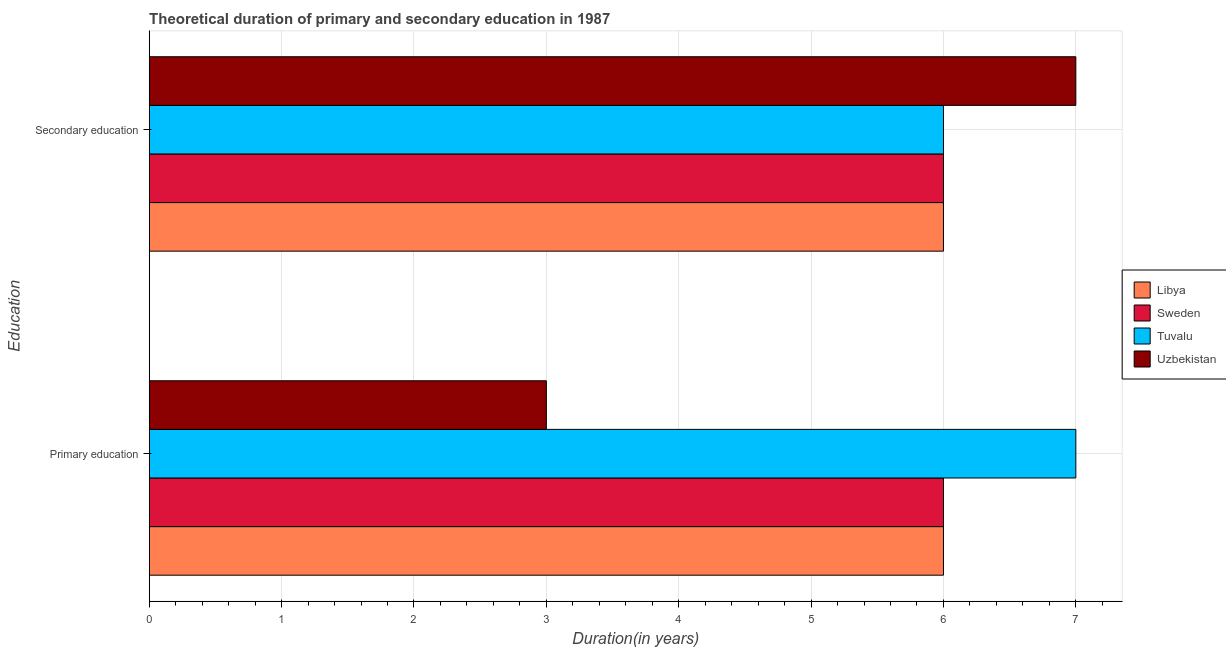Are the number of bars on each tick of the Y-axis equal?
Provide a short and direct response. Yes. What is the label of the 1st group of bars from the top?
Make the answer very short. Secondary education. Across all countries, what is the maximum duration of primary education?
Keep it short and to the point. 7. Across all countries, what is the minimum duration of primary education?
Your answer should be very brief. 3. In which country was the duration of primary education maximum?
Ensure brevity in your answer.  Tuvalu. In which country was the duration of primary education minimum?
Offer a terse response. Uzbekistan. What is the total duration of secondary education in the graph?
Your answer should be compact. 25. What is the difference between the duration of primary education in Uzbekistan and that in Tuvalu?
Ensure brevity in your answer.  -4. What is the difference between the duration of secondary education in Sweden and the duration of primary education in Uzbekistan?
Ensure brevity in your answer.  3. What is the average duration of primary education per country?
Make the answer very short. 5.5. In how many countries, is the duration of secondary education greater than the average duration of secondary education taken over all countries?
Your answer should be very brief. 1. What does the 4th bar from the top in Primary education represents?
Your answer should be compact. Libya. What does the 4th bar from the bottom in Primary education represents?
Your answer should be compact. Uzbekistan. How many bars are there?
Offer a terse response. 8. Are all the bars in the graph horizontal?
Provide a short and direct response. Yes. Are the values on the major ticks of X-axis written in scientific E-notation?
Provide a short and direct response. No. Does the graph contain any zero values?
Your answer should be compact. No. How many legend labels are there?
Offer a terse response. 4. What is the title of the graph?
Your answer should be compact. Theoretical duration of primary and secondary education in 1987. Does "Turks and Caicos Islands" appear as one of the legend labels in the graph?
Offer a terse response. No. What is the label or title of the X-axis?
Your answer should be very brief. Duration(in years). What is the label or title of the Y-axis?
Your response must be concise. Education. What is the Duration(in years) of Libya in Primary education?
Keep it short and to the point. 6. What is the Duration(in years) in Tuvalu in Primary education?
Your response must be concise. 7. What is the Duration(in years) in Uzbekistan in Primary education?
Your response must be concise. 3. What is the Duration(in years) in Tuvalu in Secondary education?
Provide a short and direct response. 6. Across all Education, what is the maximum Duration(in years) in Libya?
Your response must be concise. 6. Across all Education, what is the maximum Duration(in years) in Tuvalu?
Ensure brevity in your answer.  7. Across all Education, what is the maximum Duration(in years) of Uzbekistan?
Ensure brevity in your answer.  7. Across all Education, what is the minimum Duration(in years) in Libya?
Your response must be concise. 6. Across all Education, what is the minimum Duration(in years) in Sweden?
Make the answer very short. 6. Across all Education, what is the minimum Duration(in years) of Tuvalu?
Offer a terse response. 6. Across all Education, what is the minimum Duration(in years) in Uzbekistan?
Offer a very short reply. 3. What is the total Duration(in years) in Libya in the graph?
Make the answer very short. 12. What is the total Duration(in years) of Uzbekistan in the graph?
Your response must be concise. 10. What is the difference between the Duration(in years) in Sweden in Primary education and that in Secondary education?
Ensure brevity in your answer.  0. What is the difference between the Duration(in years) of Uzbekistan in Primary education and that in Secondary education?
Your answer should be compact. -4. What is the difference between the Duration(in years) of Libya in Primary education and the Duration(in years) of Sweden in Secondary education?
Make the answer very short. 0. What is the difference between the Duration(in years) of Libya in Primary education and the Duration(in years) of Tuvalu in Secondary education?
Ensure brevity in your answer.  0. What is the difference between the Duration(in years) in Libya in Primary education and the Duration(in years) in Uzbekistan in Secondary education?
Ensure brevity in your answer.  -1. What is the difference between the Duration(in years) of Sweden in Primary education and the Duration(in years) of Tuvalu in Secondary education?
Offer a terse response. 0. What is the average Duration(in years) of Libya per Education?
Provide a short and direct response. 6. What is the average Duration(in years) of Sweden per Education?
Make the answer very short. 6. What is the average Duration(in years) in Uzbekistan per Education?
Provide a short and direct response. 5. What is the difference between the Duration(in years) of Libya and Duration(in years) of Sweden in Primary education?
Provide a succinct answer. 0. What is the difference between the Duration(in years) in Sweden and Duration(in years) in Tuvalu in Primary education?
Offer a very short reply. -1. What is the difference between the Duration(in years) of Sweden and Duration(in years) of Uzbekistan in Primary education?
Your answer should be very brief. 3. What is the difference between the Duration(in years) of Tuvalu and Duration(in years) of Uzbekistan in Primary education?
Provide a short and direct response. 4. What is the difference between the Duration(in years) in Libya and Duration(in years) in Tuvalu in Secondary education?
Ensure brevity in your answer.  0. What is the difference between the Duration(in years) in Libya and Duration(in years) in Uzbekistan in Secondary education?
Ensure brevity in your answer.  -1. What is the difference between the Duration(in years) in Sweden and Duration(in years) in Tuvalu in Secondary education?
Offer a terse response. 0. What is the difference between the Duration(in years) of Sweden and Duration(in years) of Uzbekistan in Secondary education?
Provide a succinct answer. -1. What is the difference between the Duration(in years) of Tuvalu and Duration(in years) of Uzbekistan in Secondary education?
Your answer should be very brief. -1. What is the ratio of the Duration(in years) in Sweden in Primary education to that in Secondary education?
Provide a short and direct response. 1. What is the ratio of the Duration(in years) of Uzbekistan in Primary education to that in Secondary education?
Keep it short and to the point. 0.43. What is the difference between the highest and the second highest Duration(in years) in Libya?
Your response must be concise. 0. What is the difference between the highest and the second highest Duration(in years) in Sweden?
Keep it short and to the point. 0. What is the difference between the highest and the lowest Duration(in years) in Sweden?
Make the answer very short. 0. What is the difference between the highest and the lowest Duration(in years) in Tuvalu?
Make the answer very short. 1. 